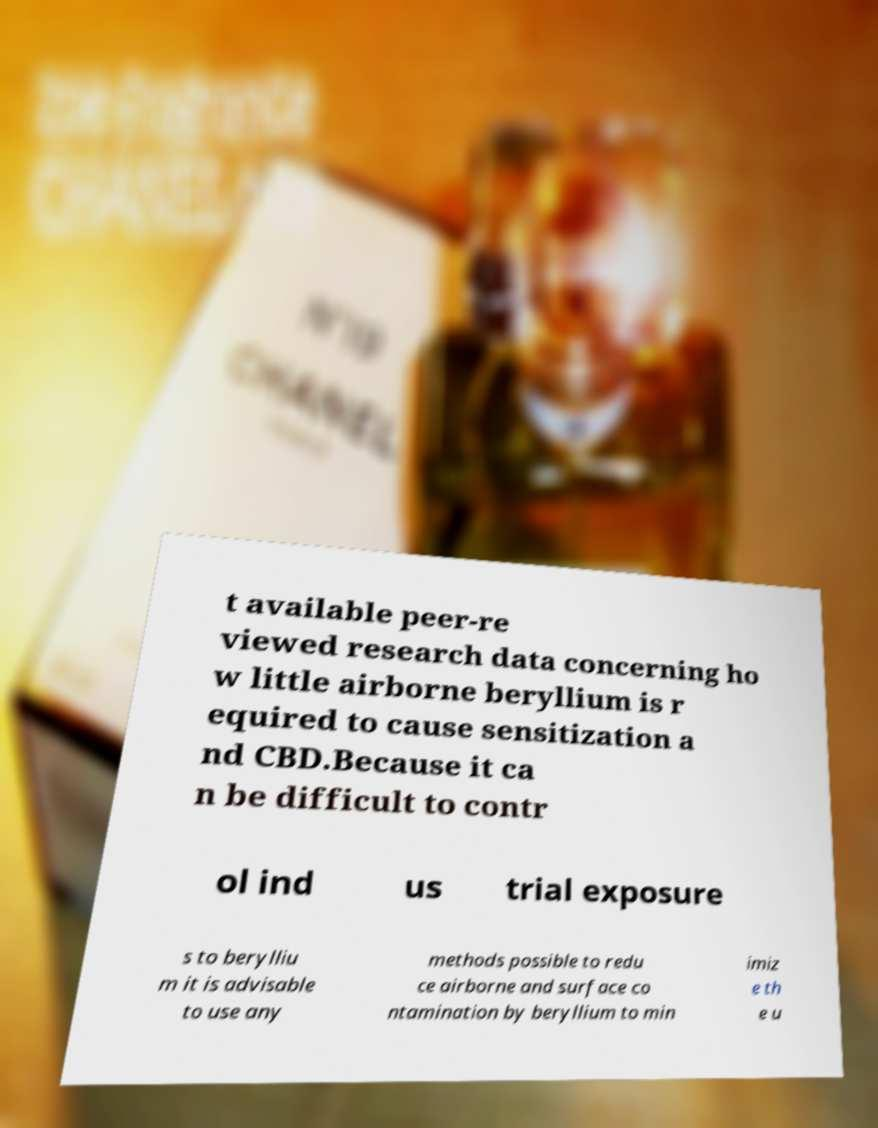There's text embedded in this image that I need extracted. Can you transcribe it verbatim? t available peer-re viewed research data concerning ho w little airborne beryllium is r equired to cause sensitization a nd CBD.Because it ca n be difficult to contr ol ind us trial exposure s to berylliu m it is advisable to use any methods possible to redu ce airborne and surface co ntamination by beryllium to min imiz e th e u 